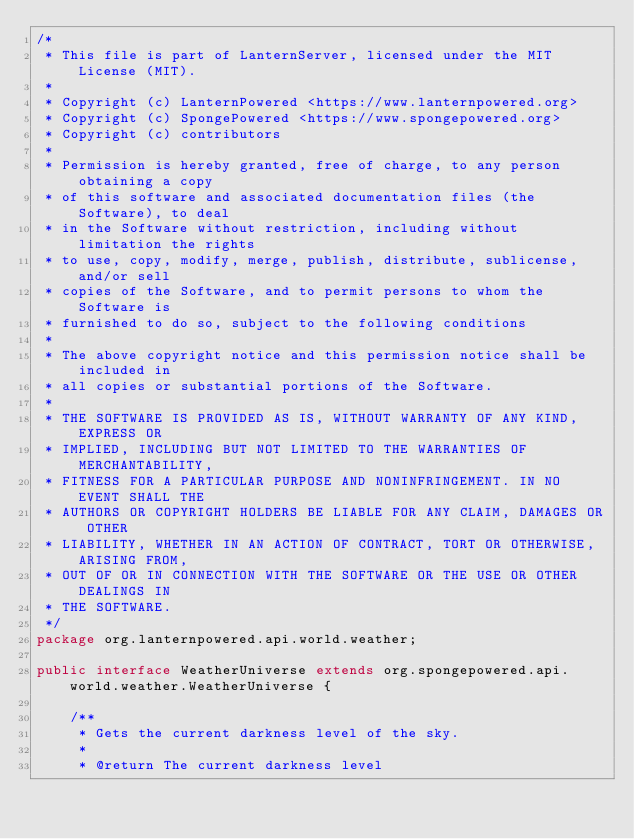Convert code to text. <code><loc_0><loc_0><loc_500><loc_500><_Java_>/*
 * This file is part of LanternServer, licensed under the MIT License (MIT).
 *
 * Copyright (c) LanternPowered <https://www.lanternpowered.org>
 * Copyright (c) SpongePowered <https://www.spongepowered.org>
 * Copyright (c) contributors
 *
 * Permission is hereby granted, free of charge, to any person obtaining a copy
 * of this software and associated documentation files (the Software), to deal
 * in the Software without restriction, including without limitation the rights
 * to use, copy, modify, merge, publish, distribute, sublicense, and/or sell
 * copies of the Software, and to permit persons to whom the Software is
 * furnished to do so, subject to the following conditions
 *
 * The above copyright notice and this permission notice shall be included in
 * all copies or substantial portions of the Software.
 *
 * THE SOFTWARE IS PROVIDED AS IS, WITHOUT WARRANTY OF ANY KIND, EXPRESS OR
 * IMPLIED, INCLUDING BUT NOT LIMITED TO THE WARRANTIES OF MERCHANTABILITY,
 * FITNESS FOR A PARTICULAR PURPOSE AND NONINFRINGEMENT. IN NO EVENT SHALL THE
 * AUTHORS OR COPYRIGHT HOLDERS BE LIABLE FOR ANY CLAIM, DAMAGES OR OTHER
 * LIABILITY, WHETHER IN AN ACTION OF CONTRACT, TORT OR OTHERWISE, ARISING FROM,
 * OUT OF OR IN CONNECTION WITH THE SOFTWARE OR THE USE OR OTHER DEALINGS IN
 * THE SOFTWARE.
 */
package org.lanternpowered.api.world.weather;

public interface WeatherUniverse extends org.spongepowered.api.world.weather.WeatherUniverse {

    /**
     * Gets the current darkness level of the sky.
     *
     * @return The current darkness level</code> 